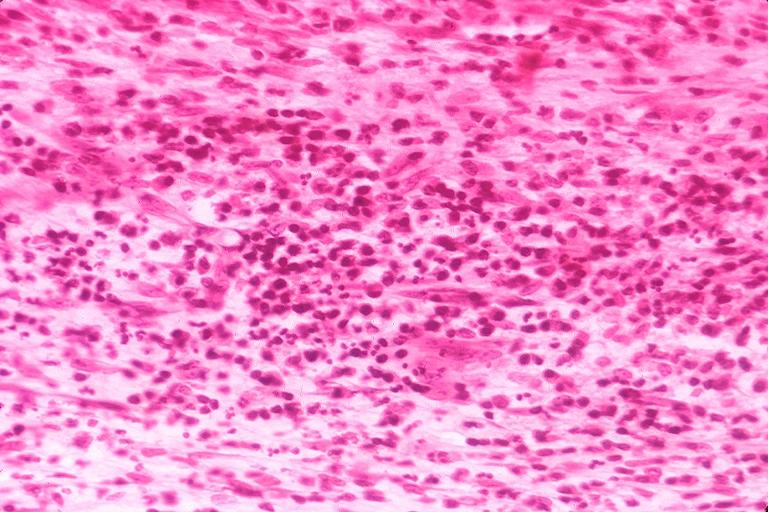s purulent sinusitis present?
Answer the question using a single word or phrase. No 